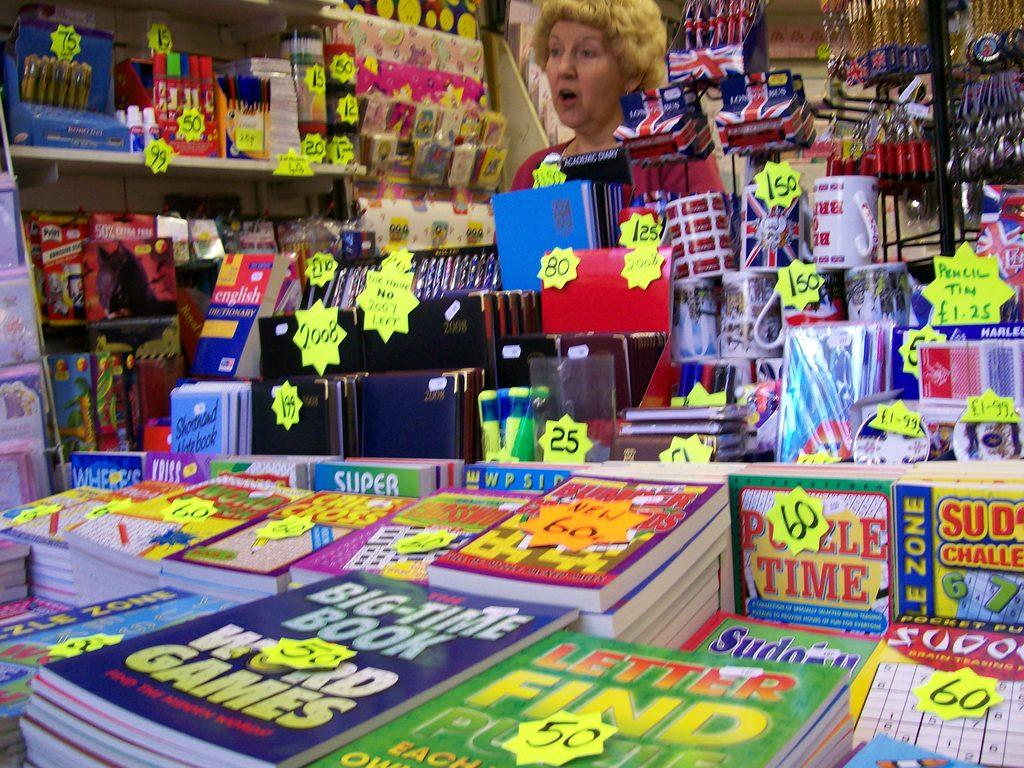Provide a one-sentence caption for the provided image. Woman working behind a counter selling books including one for Puzzle Time. 